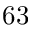<formula> <loc_0><loc_0><loc_500><loc_500>6 3</formula> 